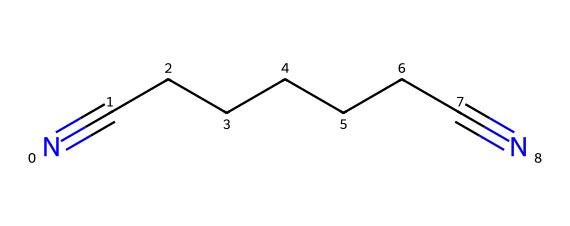What is the chemical name for the structure represented? The structure represented by the SMILES notation N#CCCCCCC#N corresponds to adiponitrile, which is a linear compound featuring two cyano groups.
Answer: adiponitrile How many carbons are in adiponitrile? By examining the carbon backbone, the SMILES indicates a total of 7 carbon atoms in the chain, as each carbon in the sequence is explicitly represented.
Answer: 7 What type of functional groups are present in adiponitrile? Adiponitrile contains cyano functional groups characterized by the presence of the nitrogen triple-bonded to carbon, identified by the N#C notation. These define it as a nitrile.
Answer: cyano groups What is the total number of nitrogen atoms in adiponitrile? There are two nitrogen atoms in adiponitrile, as indicated by the presence of N# at both ends of the carbon chain in the SMILES representation.
Answer: 2 How many double bonds are present in adiponitrile? The structure includes triple bonds between the nitrogen and carbon atoms, specifically at the ends of the chain, but there are no double bonds present in the chain itself.
Answer: 0 What is the effect of the nitrile groups on the physical properties of adiponitrile? The presence of nitrile groups increases both the boiling point and polarity of the molecule due to the strong electronegative nature of the triple-bonded nitrogens, affecting solubility and interactions.
Answer: increases polarity What type of polymer can be produced using adiponitrile? Adiponitrile is a key precursor in the production of nylon-66, which is formed through polycondensation reactions involving this molecule.
Answer: nylon-66 